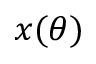Convert formula to latex. <formula><loc_0><loc_0><loc_500><loc_500>x ( \theta )</formula> 